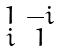<formula> <loc_0><loc_0><loc_500><loc_500>\begin{smallmatrix} 1 & - i \\ i & 1 \end{smallmatrix}</formula> 